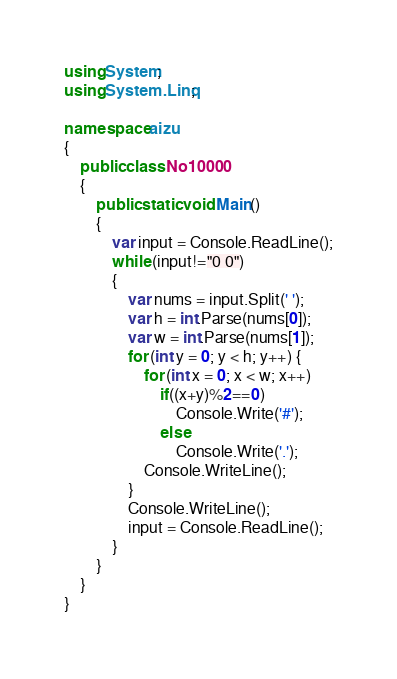Convert code to text. <code><loc_0><loc_0><loc_500><loc_500><_C#_>using System;
using System.Linq;

namespace aizu
{
    public class No10000
    {
        public static void Main()
        {
            var input = Console.ReadLine();
            while (input!="0 0")
            {
                var nums = input.Split(' ');
                var h = int.Parse(nums[0]);
                var w = int.Parse(nums[1]);
                for (int y = 0; y < h; y++) {
                    for (int x = 0; x < w; x++)
                        if((x+y)%2==0)
                            Console.Write('#');
                        else
                            Console.Write('.');
                    Console.WriteLine();
                }
                Console.WriteLine();
                input = Console.ReadLine();
            }
        }
    }
}</code> 